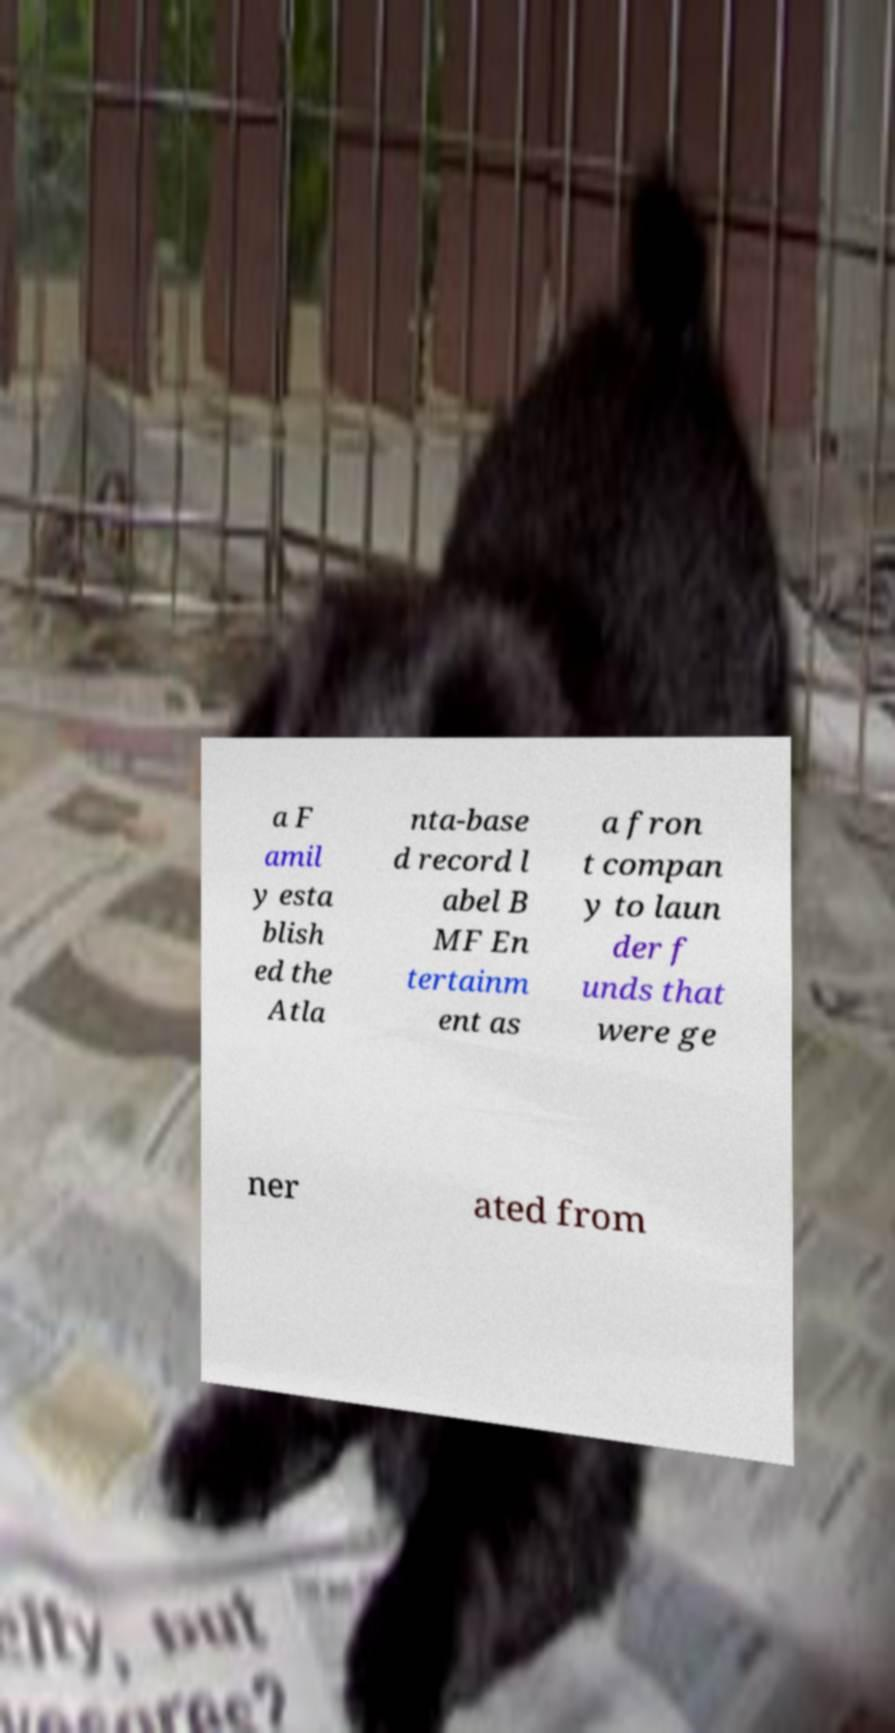Can you accurately transcribe the text from the provided image for me? a F amil y esta blish ed the Atla nta-base d record l abel B MF En tertainm ent as a fron t compan y to laun der f unds that were ge ner ated from 